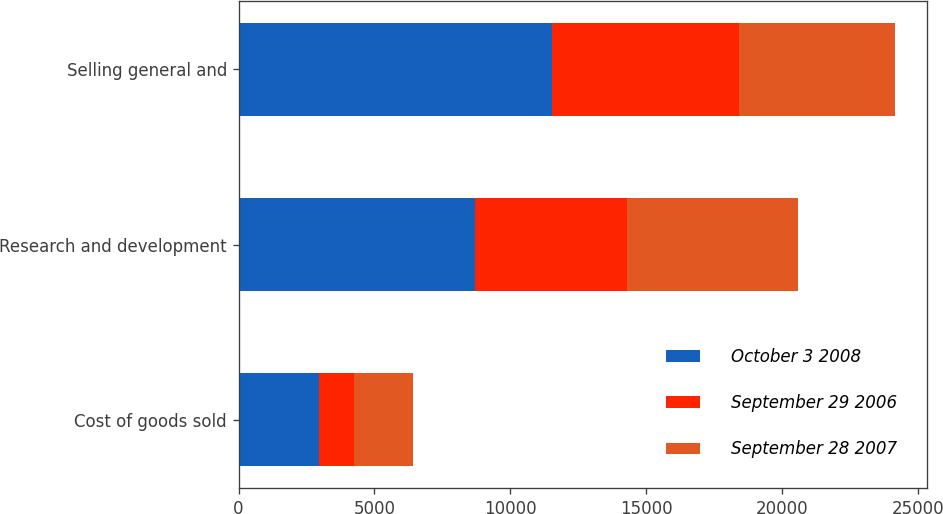Convert chart. <chart><loc_0><loc_0><loc_500><loc_500><stacked_bar_chart><ecel><fcel>Cost of goods sold<fcel>Research and development<fcel>Selling general and<nl><fcel>October 3 2008<fcel>2974<fcel>8700<fcel>11538<nl><fcel>September 29 2006<fcel>1274<fcel>5590<fcel>6873<nl><fcel>September 28 2007<fcel>2174<fcel>6311<fcel>5734<nl></chart> 